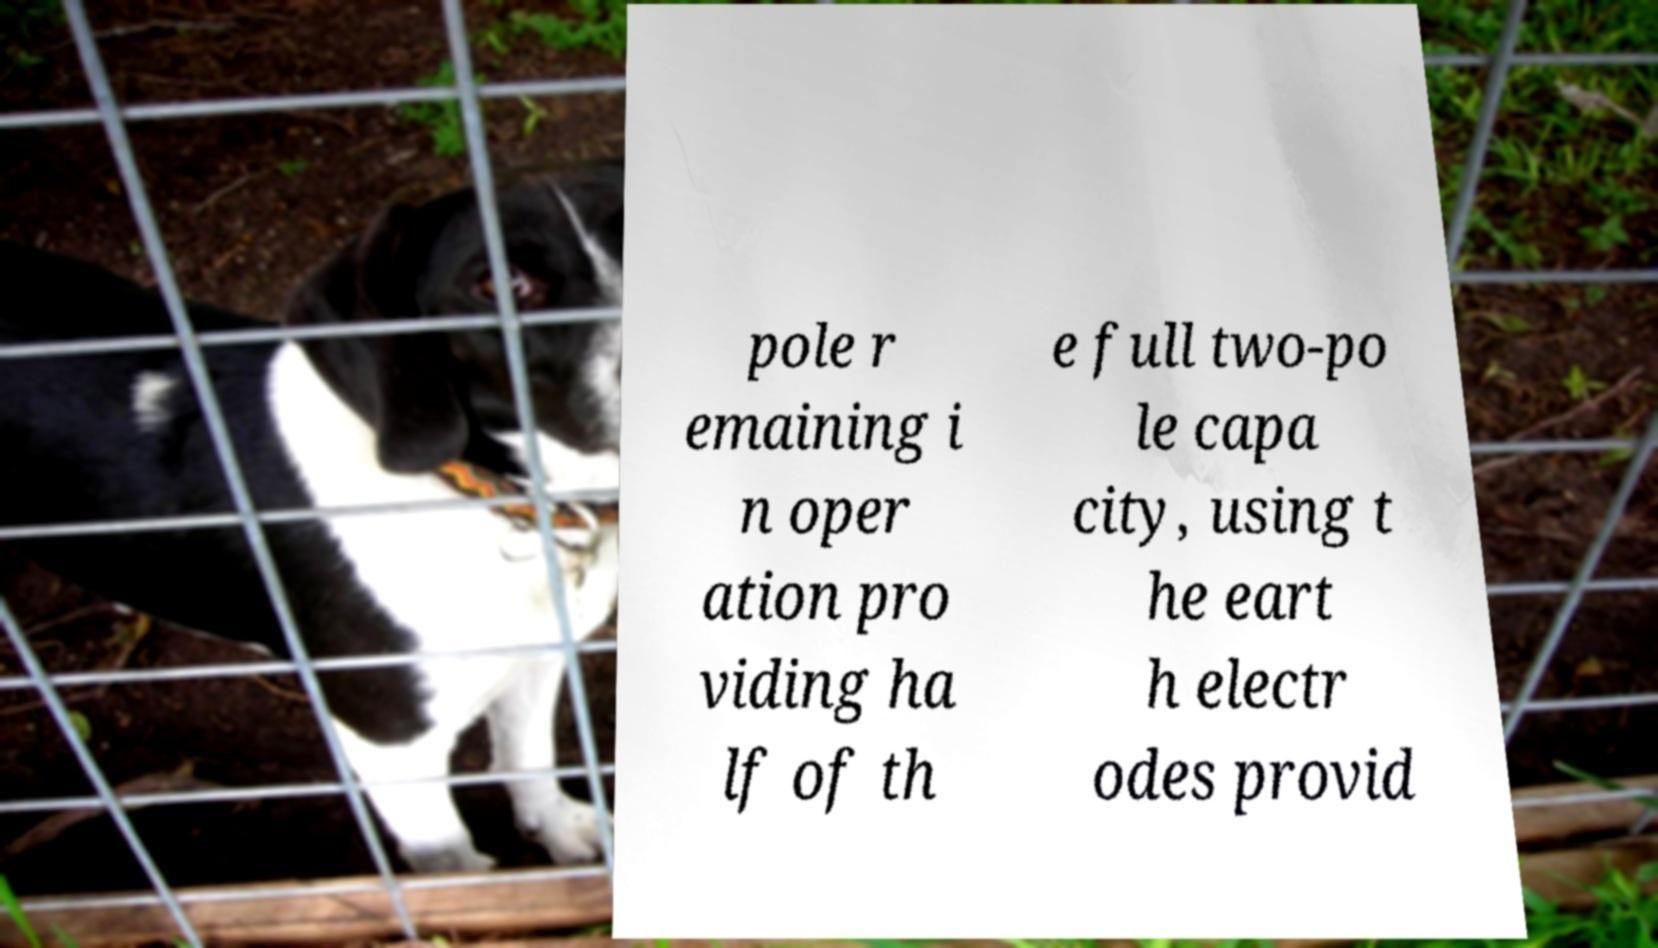For documentation purposes, I need the text within this image transcribed. Could you provide that? pole r emaining i n oper ation pro viding ha lf of th e full two-po le capa city, using t he eart h electr odes provid 